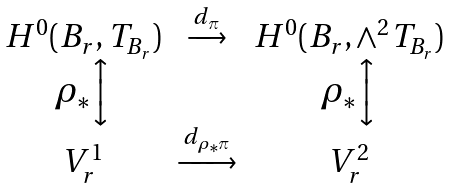<formula> <loc_0><loc_0><loc_500><loc_500>\begin{array} { c c c } H ^ { 0 } ( B _ { r } , T _ { B _ { r } } ) & \xrightarrow { d _ { \pi } } & H ^ { 0 } ( B _ { r } , \wedge ^ { 2 } T _ { B _ { r } } ) \\ \rho _ { * } \Big \updownarrow & & \rho _ { * } \Big \updownarrow \\ V ^ { 1 } _ { r } & \xrightarrow { d _ { \rho _ { * } \pi } } & V ^ { 2 } _ { r } \end{array}</formula> 